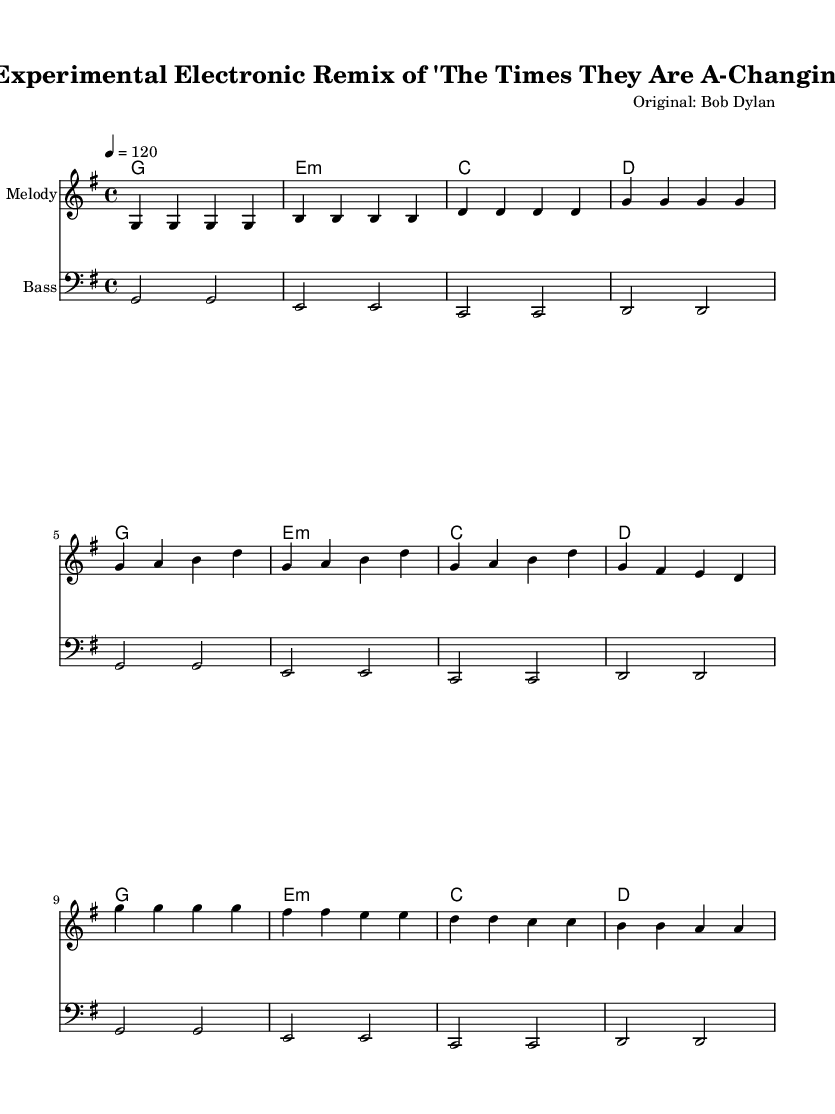What is the key signature of this music? The key signature is G major, which has one sharp (F#). This can be identified from the beginning of the score, where the key signature is indicated.
Answer: G major What is the time signature of this music? The time signature is 4/4, and this can be determined from the notation at the beginning of the score, indicating four beats per measure.
Answer: 4/4 What is the tempo marking for this piece? The tempo marking is 120 beats per minute, found at the beginning of the score which indicates the speed of the music.
Answer: 120 Identify the first chord in the harmony part. The first chord in the harmony part is G major, which is indicated right at the beginning of the chord progression.
Answer: G How many measures are in the verse section? The verse section consists of 4 measures, as can be counted from the melody and harmonies outlined specifically for that section of the song.
Answer: 4 What is the last note of the melody section? The last note of the melody section is D, which is the final note noted in the last measure of the melody part.
Answer: D How does the bass line relate to the melody in the chorus? The bass line follows a similar rhythmic pattern and notes to the melody throughout the chorus section, supporting the melody with a lower pitch range. This can be analyzed by comparing the two parts measure by measure during the chorus.
Answer: Similar pattern 